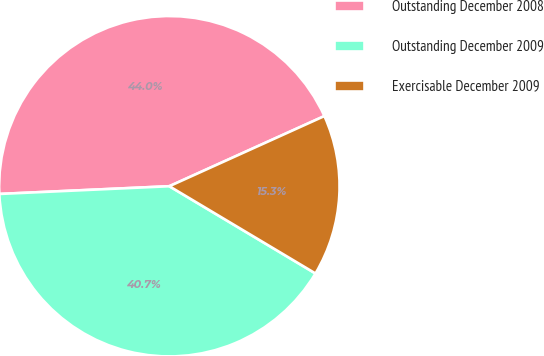Convert chart to OTSL. <chart><loc_0><loc_0><loc_500><loc_500><pie_chart><fcel>Outstanding December 2008<fcel>Outstanding December 2009<fcel>Exercisable December 2009<nl><fcel>43.96%<fcel>40.71%<fcel>15.33%<nl></chart> 